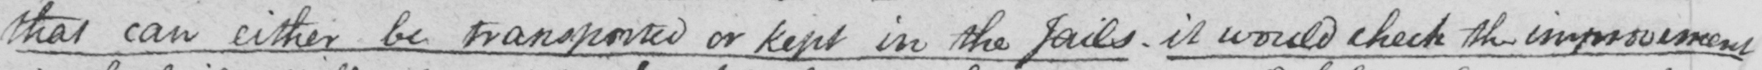Can you tell me what this handwritten text says? that can either be transported or kept in the Jails . it would check the imprisonment 